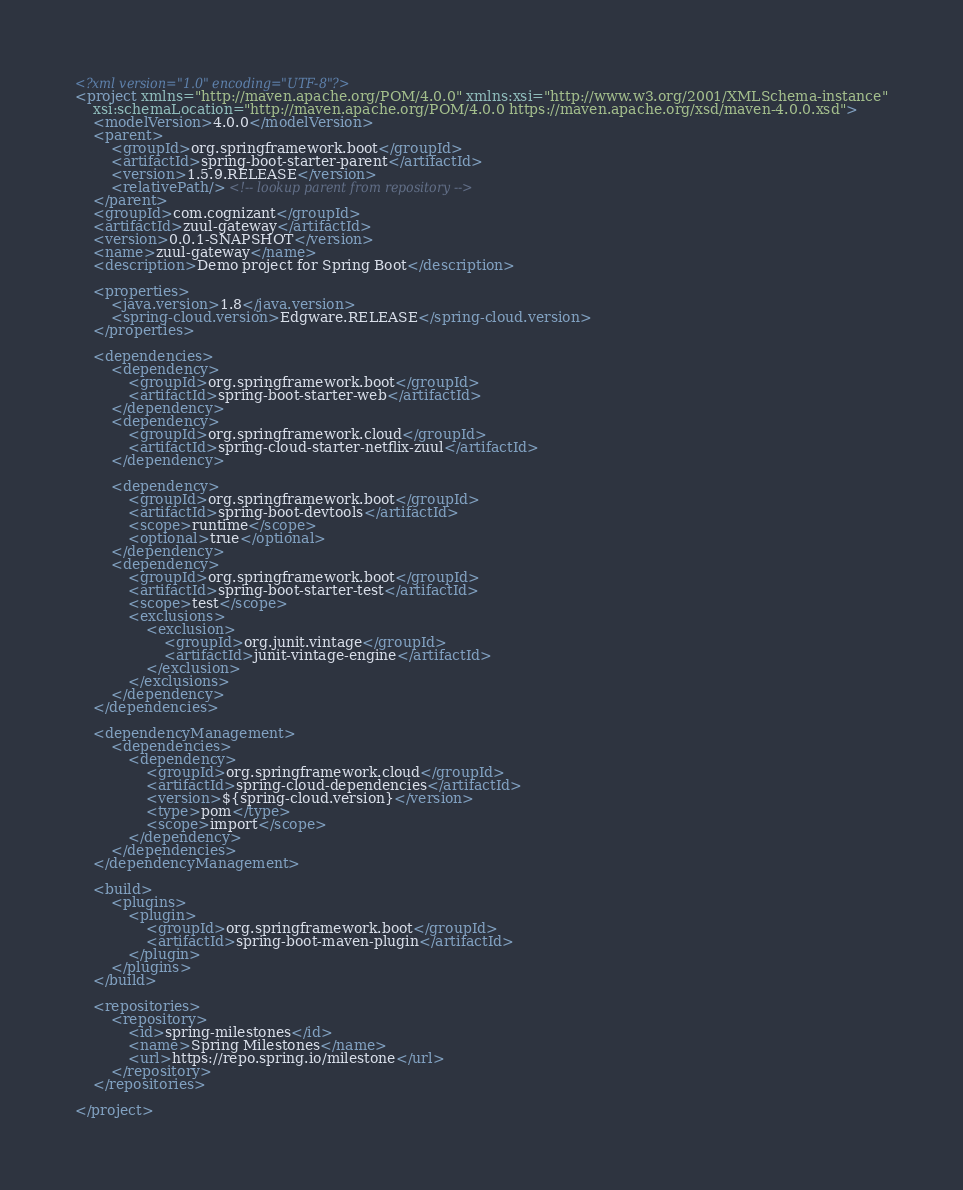<code> <loc_0><loc_0><loc_500><loc_500><_XML_><?xml version="1.0" encoding="UTF-8"?>
<project xmlns="http://maven.apache.org/POM/4.0.0" xmlns:xsi="http://www.w3.org/2001/XMLSchema-instance"
	xsi:schemaLocation="http://maven.apache.org/POM/4.0.0 https://maven.apache.org/xsd/maven-4.0.0.xsd">
	<modelVersion>4.0.0</modelVersion>
	<parent>
		<groupId>org.springframework.boot</groupId>
		<artifactId>spring-boot-starter-parent</artifactId>
		<version>1.5.9.RELEASE</version>
		<relativePath/> <!-- lookup parent from repository -->
	</parent>
	<groupId>com.cognizant</groupId>
	<artifactId>zuul-gateway</artifactId>
	<version>0.0.1-SNAPSHOT</version>
	<name>zuul-gateway</name>
	<description>Demo project for Spring Boot</description>

	<properties>
		<java.version>1.8</java.version>
		<spring-cloud.version>Edgware.RELEASE</spring-cloud.version>
	</properties>

	<dependencies>
		<dependency>
			<groupId>org.springframework.boot</groupId>
			<artifactId>spring-boot-starter-web</artifactId>
		</dependency>
		<dependency>
			<groupId>org.springframework.cloud</groupId>
			<artifactId>spring-cloud-starter-netflix-zuul</artifactId>
		</dependency>

		<dependency>
			<groupId>org.springframework.boot</groupId>
			<artifactId>spring-boot-devtools</artifactId>
			<scope>runtime</scope>
			<optional>true</optional>
		</dependency>
		<dependency>
			<groupId>org.springframework.boot</groupId>
			<artifactId>spring-boot-starter-test</artifactId>
			<scope>test</scope>
			<exclusions>
				<exclusion>
					<groupId>org.junit.vintage</groupId>
					<artifactId>junit-vintage-engine</artifactId>
				</exclusion>
			</exclusions>
		</dependency>
	</dependencies>

	<dependencyManagement>
		<dependencies>
			<dependency>
				<groupId>org.springframework.cloud</groupId>
				<artifactId>spring-cloud-dependencies</artifactId>
				<version>${spring-cloud.version}</version>
				<type>pom</type>
				<scope>import</scope>
			</dependency>
		</dependencies>
	</dependencyManagement>

	<build>
		<plugins>
			<plugin>
				<groupId>org.springframework.boot</groupId>
				<artifactId>spring-boot-maven-plugin</artifactId>
			</plugin>
		</plugins>
	</build>

	<repositories>
		<repository>
			<id>spring-milestones</id>
			<name>Spring Milestones</name>
			<url>https://repo.spring.io/milestone</url>
		</repository>
	</repositories>

</project>
</code> 